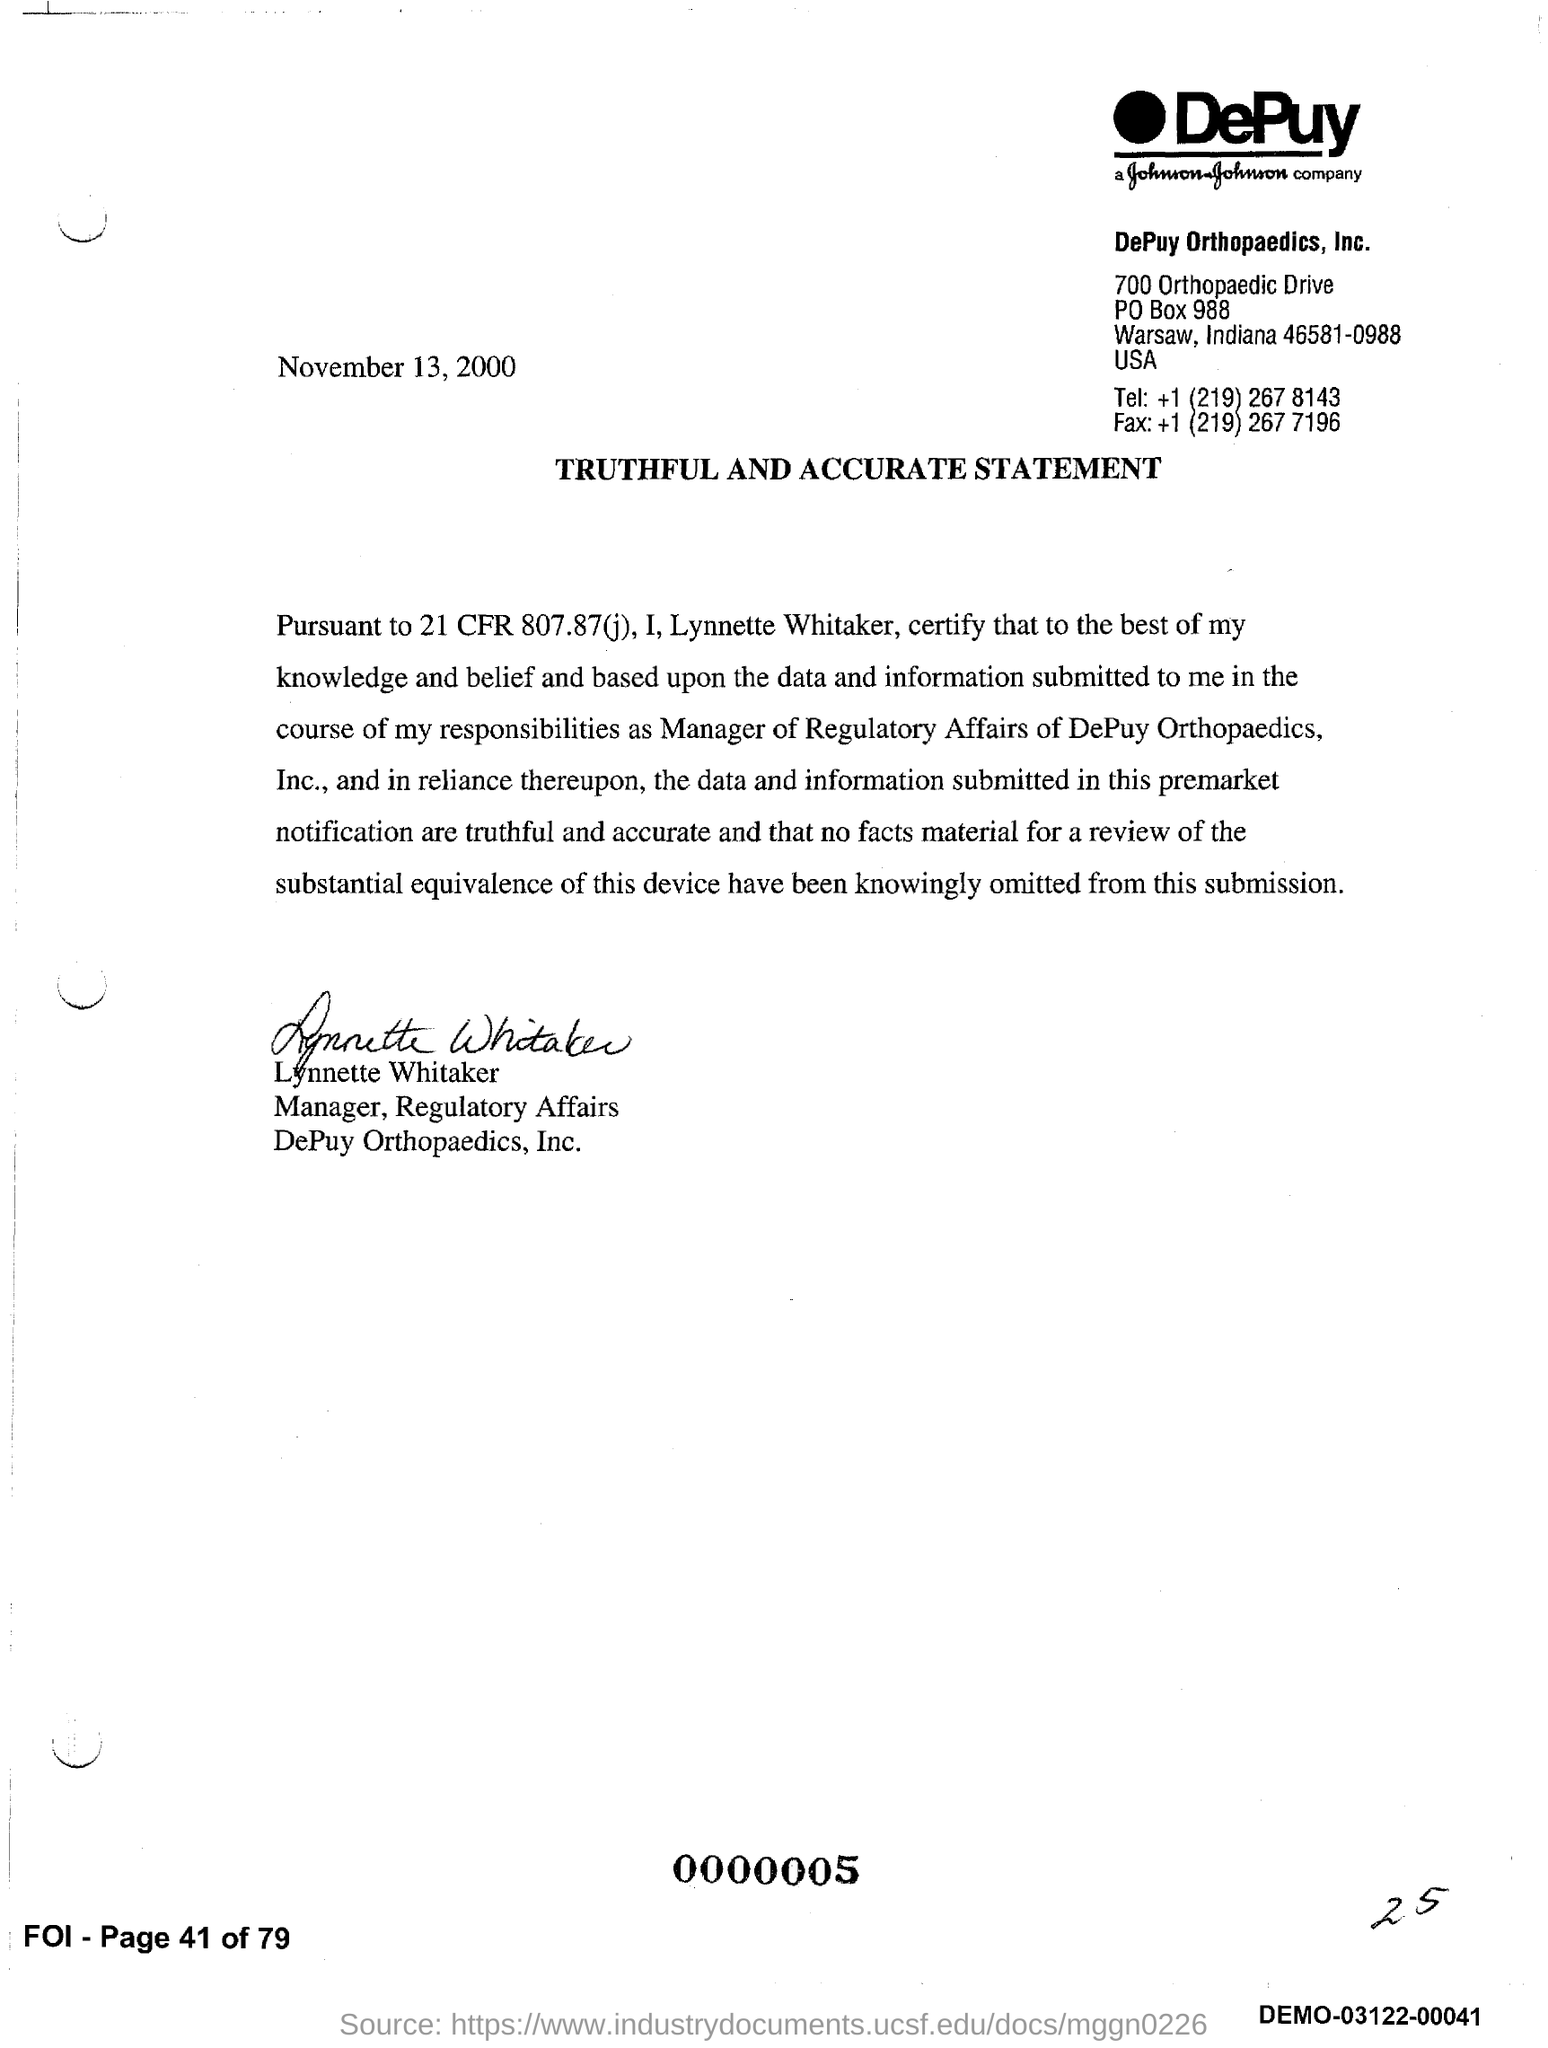Draw attention to some important aspects in this diagram. The document was signed by Lynnette Whitaker. The title of the document is 'Truthful and Accurate Statement.' 